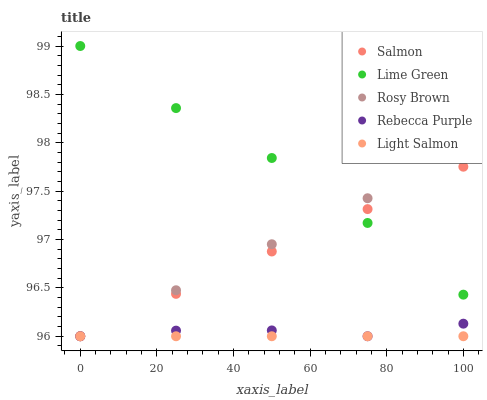Does Light Salmon have the minimum area under the curve?
Answer yes or no. Yes. Does Lime Green have the maximum area under the curve?
Answer yes or no. Yes. Does Rosy Brown have the minimum area under the curve?
Answer yes or no. No. Does Rosy Brown have the maximum area under the curve?
Answer yes or no. No. Is Light Salmon the smoothest?
Answer yes or no. Yes. Is Lime Green the roughest?
Answer yes or no. Yes. Is Salmon the smoothest?
Answer yes or no. No. Is Salmon the roughest?
Answer yes or no. No. Does Light Salmon have the lowest value?
Answer yes or no. Yes. Does Lime Green have the highest value?
Answer yes or no. Yes. Does Rosy Brown have the highest value?
Answer yes or no. No. Is Rebecca Purple less than Lime Green?
Answer yes or no. Yes. Is Lime Green greater than Light Salmon?
Answer yes or no. Yes. Does Salmon intersect Lime Green?
Answer yes or no. Yes. Is Salmon less than Lime Green?
Answer yes or no. No. Is Salmon greater than Lime Green?
Answer yes or no. No. Does Rebecca Purple intersect Lime Green?
Answer yes or no. No. 